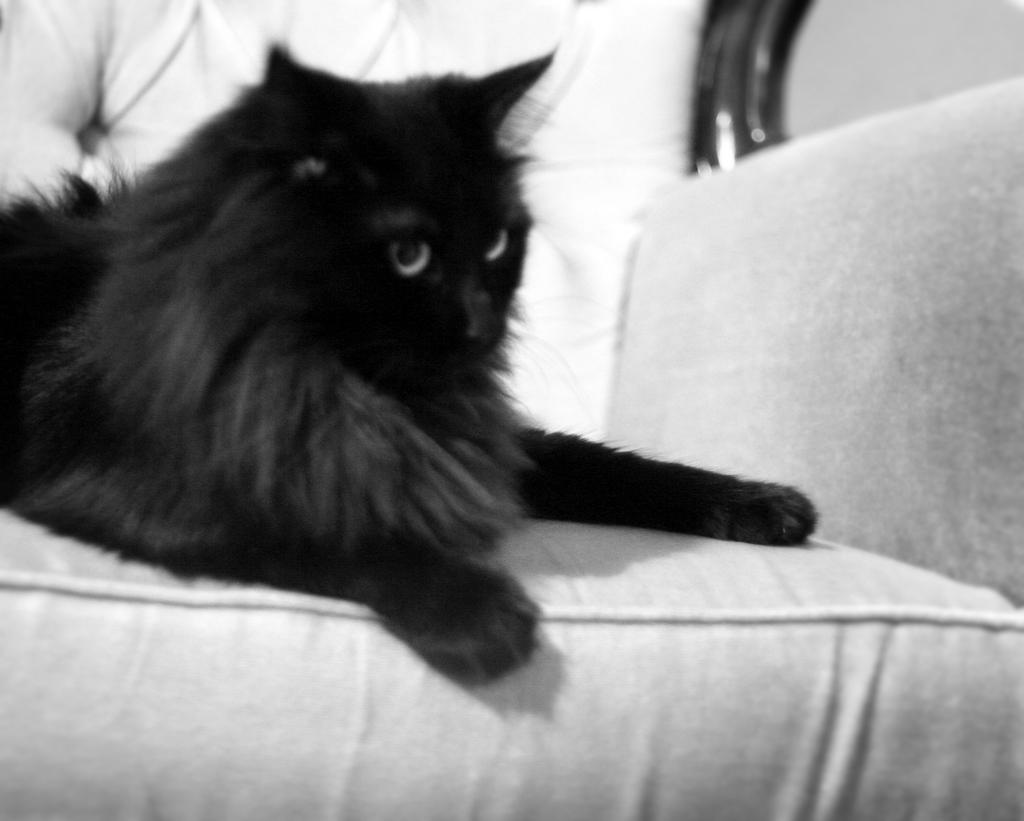What type of animal is in the image? There is a black cat in the image. Where is the cat located in the image? The cat is sitting on a sofa. What type of pin is the minister using to hold the cat's collar in the image? There is no minister or pin present in the image, and the cat is not wearing a collar. 